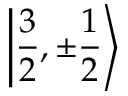<formula> <loc_0><loc_0><loc_500><loc_500>\left | { \frac { 3 } { 2 } } , \pm { \frac { 1 } { 2 } } \right \rangle</formula> 